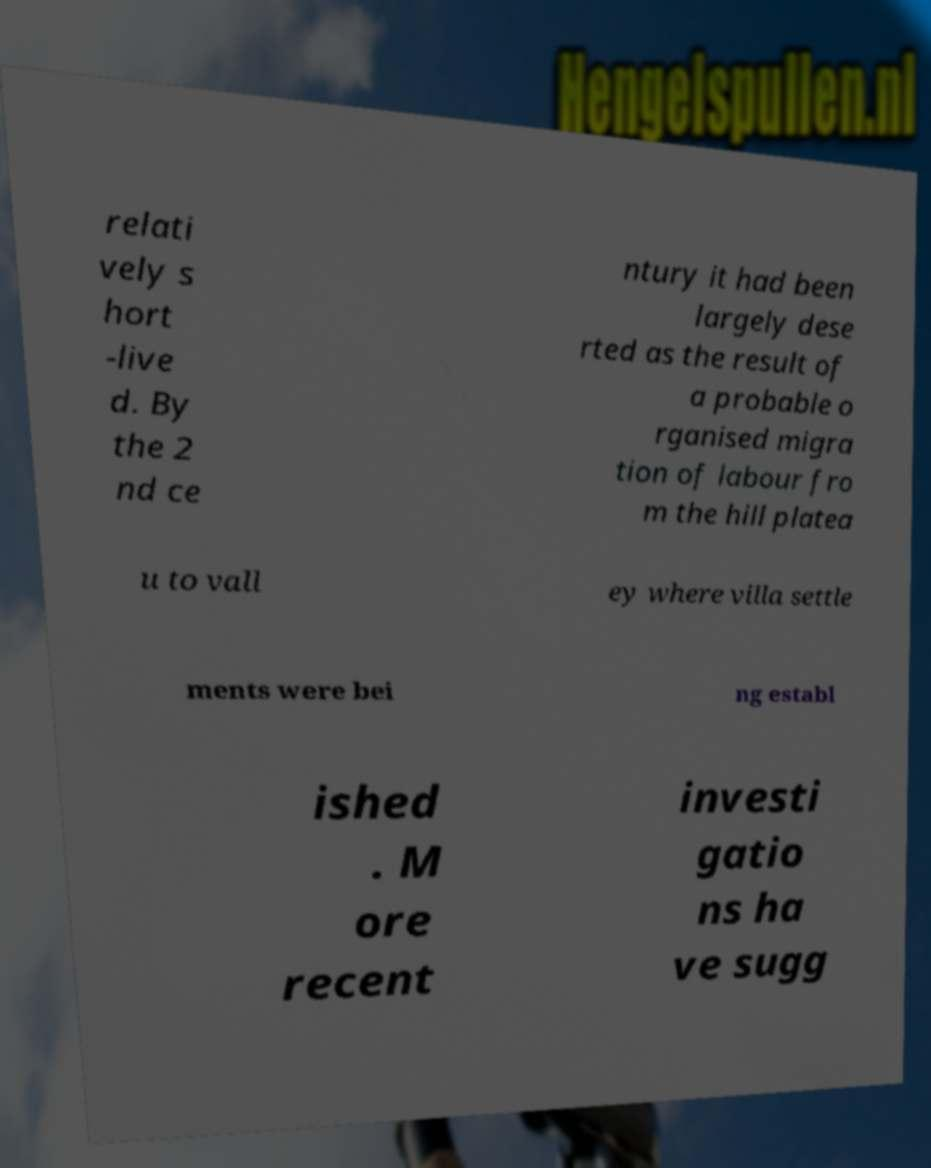Can you accurately transcribe the text from the provided image for me? relati vely s hort -live d. By the 2 nd ce ntury it had been largely dese rted as the result of a probable o rganised migra tion of labour fro m the hill platea u to vall ey where villa settle ments were bei ng establ ished . M ore recent investi gatio ns ha ve sugg 